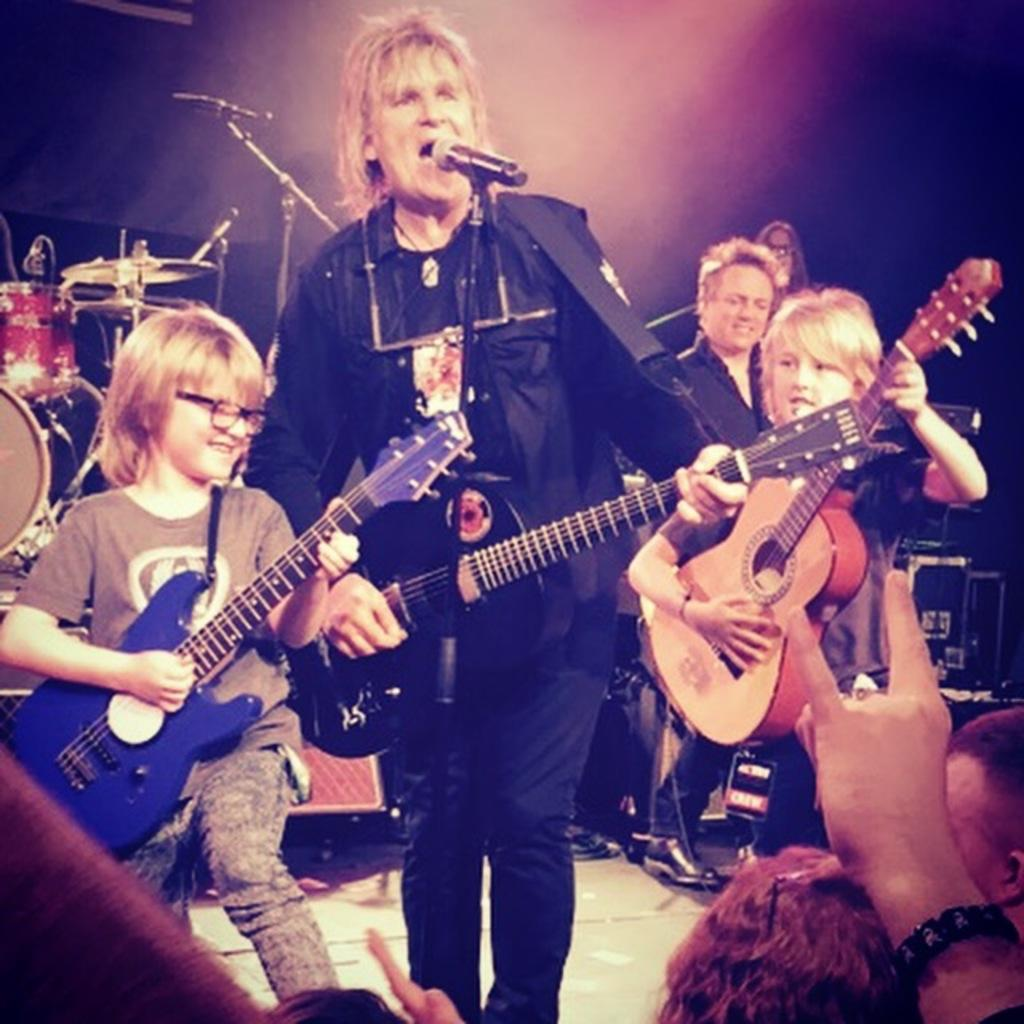What is happening in the image? There is a group of people in the image, and they are playing musical instruments. What are the people doing together? The people are playing musical instruments, which suggests they might be performing or practicing together. Where is the lake located in the image? There is no lake present in the image; it features a group of people playing musical instruments. What thoughts are going through the minds of the people in the image? We cannot determine the thoughts of the people in the image based on the provided facts. 